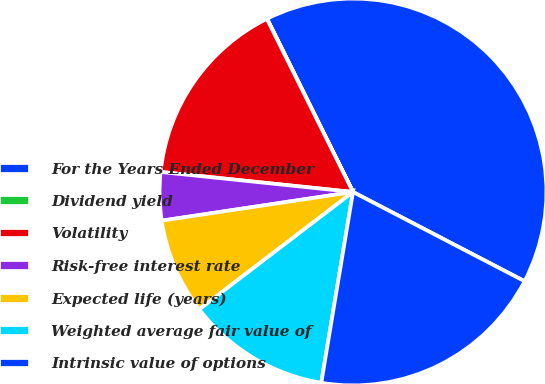<chart> <loc_0><loc_0><loc_500><loc_500><pie_chart><fcel>For the Years Ended December<fcel>Dividend yield<fcel>Volatility<fcel>Risk-free interest rate<fcel>Expected life (years)<fcel>Weighted average fair value of<fcel>Intrinsic value of options<nl><fcel>39.96%<fcel>0.02%<fcel>16.0%<fcel>4.02%<fcel>8.01%<fcel>12.0%<fcel>19.99%<nl></chart> 